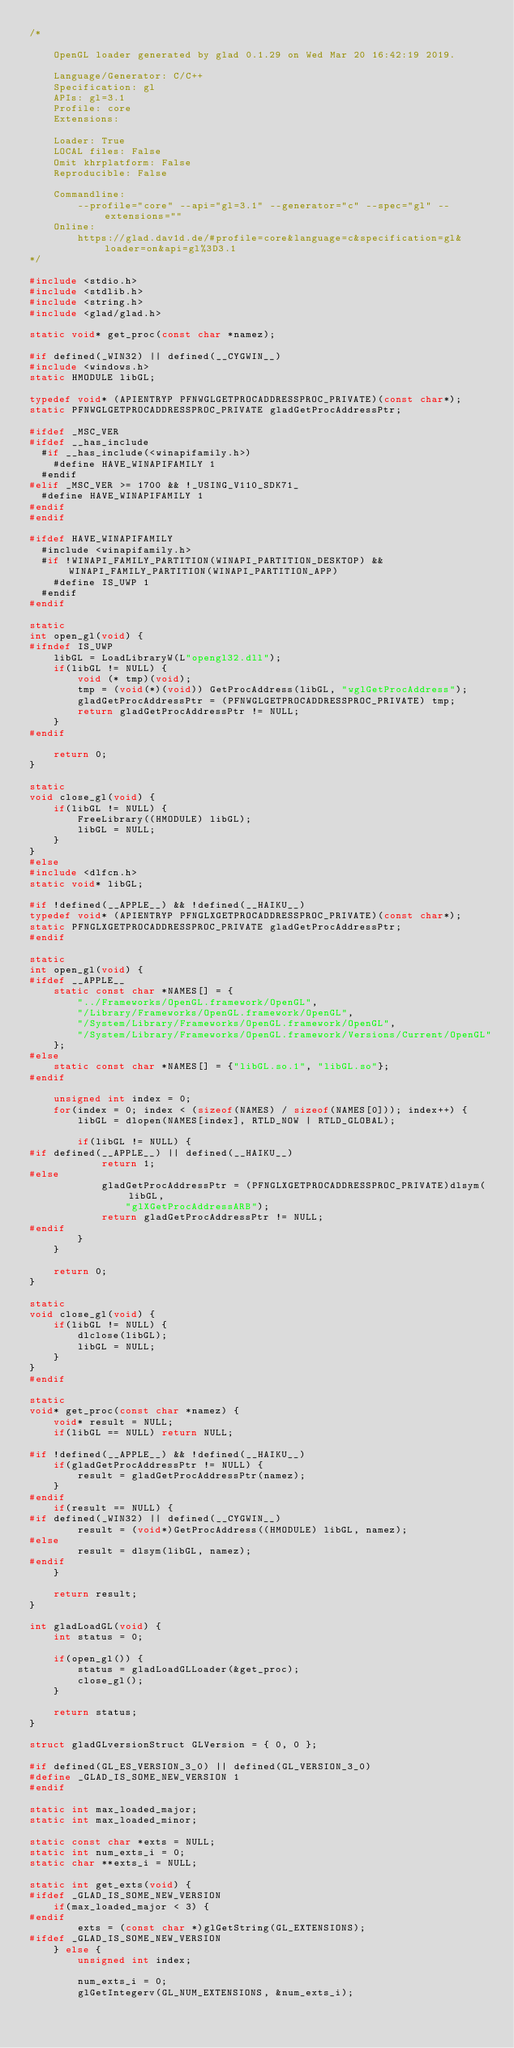<code> <loc_0><loc_0><loc_500><loc_500><_C_>/*

    OpenGL loader generated by glad 0.1.29 on Wed Mar 20 16:42:19 2019.

    Language/Generator: C/C++
    Specification: gl
    APIs: gl=3.1
    Profile: core
    Extensions:
        
    Loader: True
    LOCAL files: False
    Omit khrplatform: False
    Reproducible: False

    Commandline:
        --profile="core" --api="gl=3.1" --generator="c" --spec="gl" --extensions=""
    Online:
        https://glad.dav1d.de/#profile=core&language=c&specification=gl&loader=on&api=gl%3D3.1
*/

#include <stdio.h>
#include <stdlib.h>
#include <string.h>
#include <glad/glad.h>

static void* get_proc(const char *namez);

#if defined(_WIN32) || defined(__CYGWIN__)
#include <windows.h>
static HMODULE libGL;

typedef void* (APIENTRYP PFNWGLGETPROCADDRESSPROC_PRIVATE)(const char*);
static PFNWGLGETPROCADDRESSPROC_PRIVATE gladGetProcAddressPtr;

#ifdef _MSC_VER
#ifdef __has_include
  #if __has_include(<winapifamily.h>)
    #define HAVE_WINAPIFAMILY 1
  #endif
#elif _MSC_VER >= 1700 && !_USING_V110_SDK71_
  #define HAVE_WINAPIFAMILY 1
#endif
#endif

#ifdef HAVE_WINAPIFAMILY
  #include <winapifamily.h>
  #if !WINAPI_FAMILY_PARTITION(WINAPI_PARTITION_DESKTOP) && WINAPI_FAMILY_PARTITION(WINAPI_PARTITION_APP)
    #define IS_UWP 1
  #endif
#endif

static
int open_gl(void) {
#ifndef IS_UWP
    libGL = LoadLibraryW(L"opengl32.dll");
    if(libGL != NULL) {
        void (* tmp)(void);
        tmp = (void(*)(void)) GetProcAddress(libGL, "wglGetProcAddress");
        gladGetProcAddressPtr = (PFNWGLGETPROCADDRESSPROC_PRIVATE) tmp;
        return gladGetProcAddressPtr != NULL;
    }
#endif

    return 0;
}

static
void close_gl(void) {
    if(libGL != NULL) {
        FreeLibrary((HMODULE) libGL);
        libGL = NULL;
    }
}
#else
#include <dlfcn.h>
static void* libGL;

#if !defined(__APPLE__) && !defined(__HAIKU__)
typedef void* (APIENTRYP PFNGLXGETPROCADDRESSPROC_PRIVATE)(const char*);
static PFNGLXGETPROCADDRESSPROC_PRIVATE gladGetProcAddressPtr;
#endif

static
int open_gl(void) {
#ifdef __APPLE__
    static const char *NAMES[] = {
        "../Frameworks/OpenGL.framework/OpenGL",
        "/Library/Frameworks/OpenGL.framework/OpenGL",
        "/System/Library/Frameworks/OpenGL.framework/OpenGL",
        "/System/Library/Frameworks/OpenGL.framework/Versions/Current/OpenGL"
    };
#else
    static const char *NAMES[] = {"libGL.so.1", "libGL.so"};
#endif

    unsigned int index = 0;
    for(index = 0; index < (sizeof(NAMES) / sizeof(NAMES[0])); index++) {
        libGL = dlopen(NAMES[index], RTLD_NOW | RTLD_GLOBAL);

        if(libGL != NULL) {
#if defined(__APPLE__) || defined(__HAIKU__)
            return 1;
#else
            gladGetProcAddressPtr = (PFNGLXGETPROCADDRESSPROC_PRIVATE)dlsym(libGL,
                "glXGetProcAddressARB");
            return gladGetProcAddressPtr != NULL;
#endif
        }
    }

    return 0;
}

static
void close_gl(void) {
    if(libGL != NULL) {
        dlclose(libGL);
        libGL = NULL;
    }
}
#endif

static
void* get_proc(const char *namez) {
    void* result = NULL;
    if(libGL == NULL) return NULL;

#if !defined(__APPLE__) && !defined(__HAIKU__)
    if(gladGetProcAddressPtr != NULL) {
        result = gladGetProcAddressPtr(namez);
    }
#endif
    if(result == NULL) {
#if defined(_WIN32) || defined(__CYGWIN__)
        result = (void*)GetProcAddress((HMODULE) libGL, namez);
#else
        result = dlsym(libGL, namez);
#endif
    }

    return result;
}

int gladLoadGL(void) {
    int status = 0;

    if(open_gl()) {
        status = gladLoadGLLoader(&get_proc);
        close_gl();
    }

    return status;
}

struct gladGLversionStruct GLVersion = { 0, 0 };

#if defined(GL_ES_VERSION_3_0) || defined(GL_VERSION_3_0)
#define _GLAD_IS_SOME_NEW_VERSION 1
#endif

static int max_loaded_major;
static int max_loaded_minor;

static const char *exts = NULL;
static int num_exts_i = 0;
static char **exts_i = NULL;

static int get_exts(void) {
#ifdef _GLAD_IS_SOME_NEW_VERSION
    if(max_loaded_major < 3) {
#endif
        exts = (const char *)glGetString(GL_EXTENSIONS);
#ifdef _GLAD_IS_SOME_NEW_VERSION
    } else {
        unsigned int index;

        num_exts_i = 0;
        glGetIntegerv(GL_NUM_EXTENSIONS, &num_exts_i);</code> 